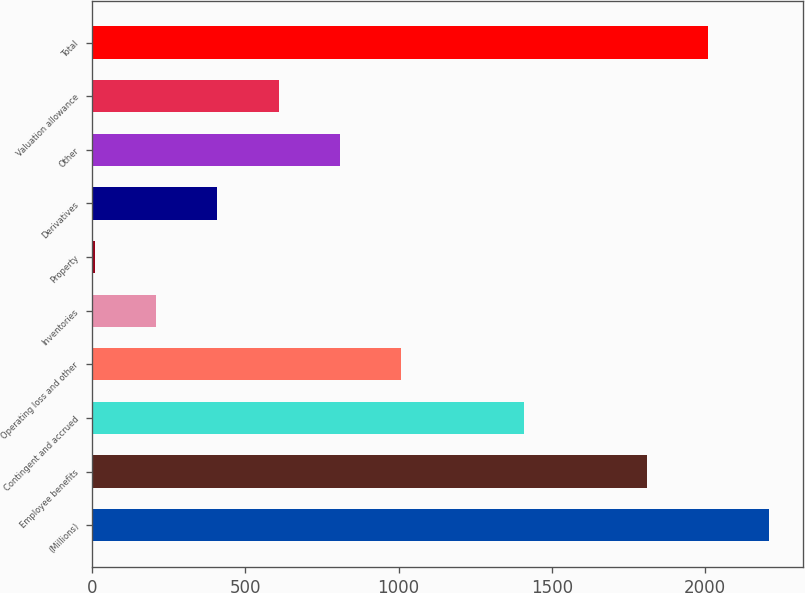Convert chart. <chart><loc_0><loc_0><loc_500><loc_500><bar_chart><fcel>(Millions)<fcel>Employee benefits<fcel>Contingent and accrued<fcel>Operating loss and other<fcel>Inventories<fcel>Property<fcel>Derivatives<fcel>Other<fcel>Valuation allowance<fcel>Total<nl><fcel>2210.2<fcel>1809.8<fcel>1409.4<fcel>1009<fcel>208.2<fcel>8<fcel>408.4<fcel>808.8<fcel>608.6<fcel>2010<nl></chart> 